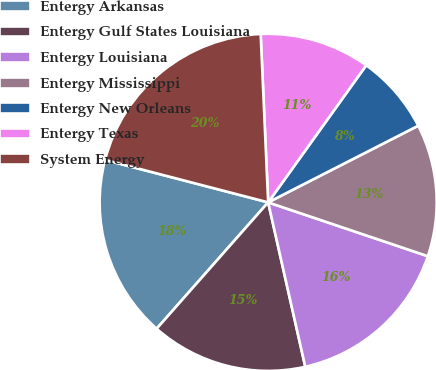Convert chart. <chart><loc_0><loc_0><loc_500><loc_500><pie_chart><fcel>Entergy Arkansas<fcel>Entergy Gulf States Louisiana<fcel>Entergy Louisiana<fcel>Entergy Mississippi<fcel>Entergy New Orleans<fcel>Entergy Texas<fcel>System Energy<nl><fcel>17.54%<fcel>15.04%<fcel>16.29%<fcel>12.69%<fcel>7.6%<fcel>10.59%<fcel>20.24%<nl></chart> 